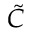Convert formula to latex. <formula><loc_0><loc_0><loc_500><loc_500>\tilde { C }</formula> 